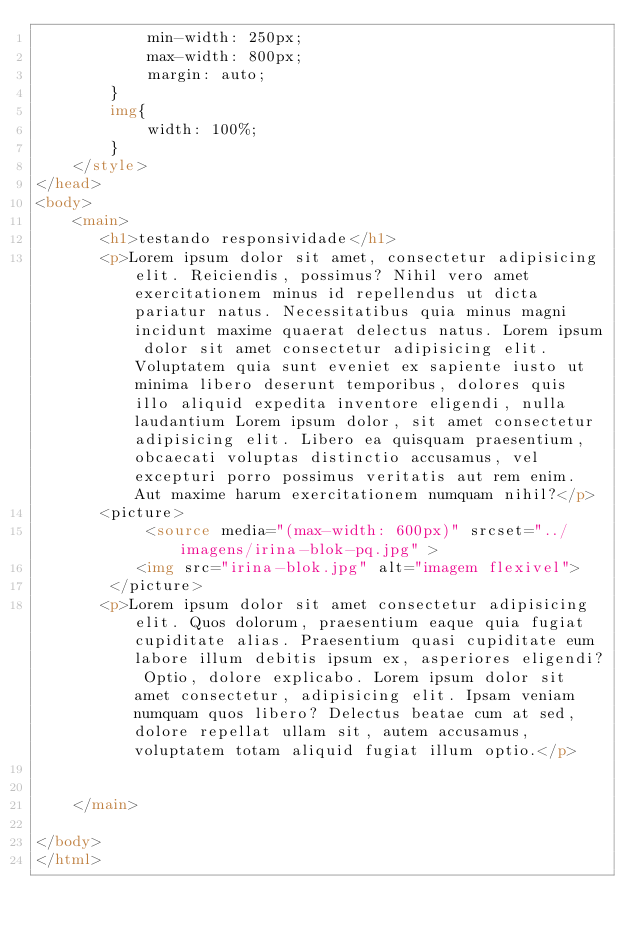Convert code to text. <code><loc_0><loc_0><loc_500><loc_500><_HTML_>            min-width: 250px;
            max-width: 800px;
            margin: auto;
        }
        img{
            width: 100%;
        }
    </style>
</head>
<body>
    <main>
       <h1>testando responsividade</h1>
       <p>Lorem ipsum dolor sit amet, consectetur adipisicing elit. Reiciendis, possimus? Nihil vero amet exercitationem minus id repellendus ut dicta pariatur natus. Necessitatibus quia minus magni incidunt maxime quaerat delectus natus. Lorem ipsum dolor sit amet consectetur adipisicing elit. Voluptatem quia sunt eveniet ex sapiente iusto ut minima libero deserunt temporibus, dolores quis illo aliquid expedita inventore eligendi, nulla laudantium Lorem ipsum dolor, sit amet consectetur adipisicing elit. Libero ea quisquam praesentium, obcaecati voluptas distinctio accusamus, vel excepturi porro possimus veritatis aut rem enim. Aut maxime harum exercitationem numquam nihil?</p>
       <picture>
            <source media="(max-width: 600px)" srcset="../imagens/irina-blok-pq.jpg" >
           <img src="irina-blok.jpg" alt="imagem flexivel">
        </picture>
       <p>Lorem ipsum dolor sit amet consectetur adipisicing elit. Quos dolorum, praesentium eaque quia fugiat cupiditate alias. Praesentium quasi cupiditate eum labore illum debitis ipsum ex, asperiores eligendi? Optio, dolore explicabo. Lorem ipsum dolor sit amet consectetur, adipisicing elit. Ipsam veniam numquam quos libero? Delectus beatae cum at sed, dolore repellat ullam sit, autem accusamus, voluptatem totam aliquid fugiat illum optio.</p>
    
    
    </main>
    
</body>
</html></code> 